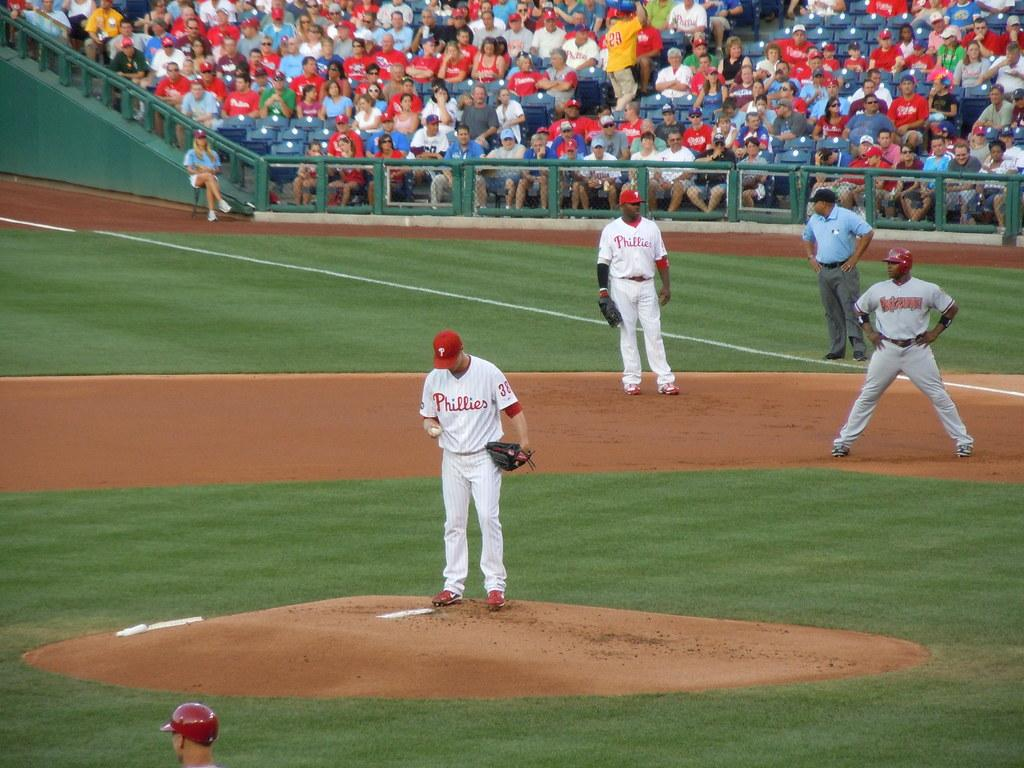<image>
Offer a succinct explanation of the picture presented. The phillies pitcher stands on the mound preparing to pitch 